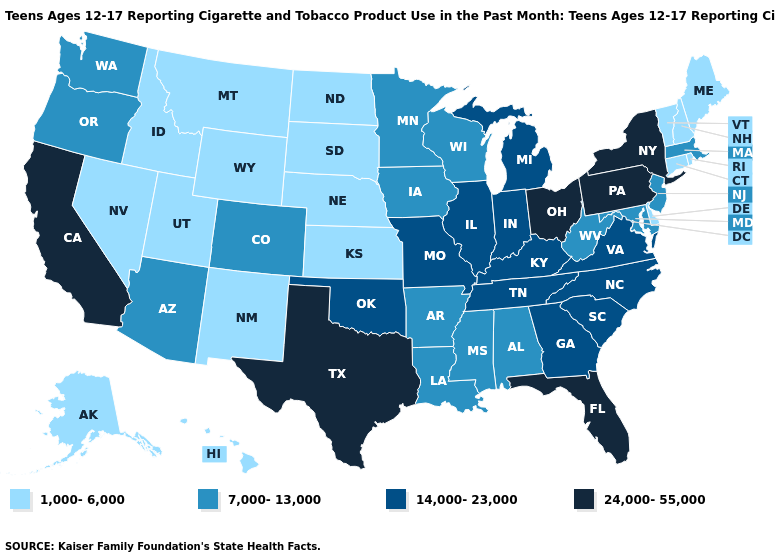Which states have the highest value in the USA?
Be succinct. California, Florida, New York, Ohio, Pennsylvania, Texas. What is the value of Maine?
Quick response, please. 1,000-6,000. Among the states that border Pennsylvania , which have the highest value?
Answer briefly. New York, Ohio. What is the value of Maine?
Answer briefly. 1,000-6,000. Among the states that border New Mexico , does Arizona have the highest value?
Quick response, please. No. Which states hav the highest value in the South?
Concise answer only. Florida, Texas. What is the highest value in states that border New York?
Answer briefly. 24,000-55,000. How many symbols are there in the legend?
Give a very brief answer. 4. What is the value of South Dakota?
Answer briefly. 1,000-6,000. Is the legend a continuous bar?
Be succinct. No. What is the value of Michigan?
Quick response, please. 14,000-23,000. What is the value of Idaho?
Be succinct. 1,000-6,000. What is the value of South Dakota?
Write a very short answer. 1,000-6,000. What is the value of Colorado?
Be succinct. 7,000-13,000. 